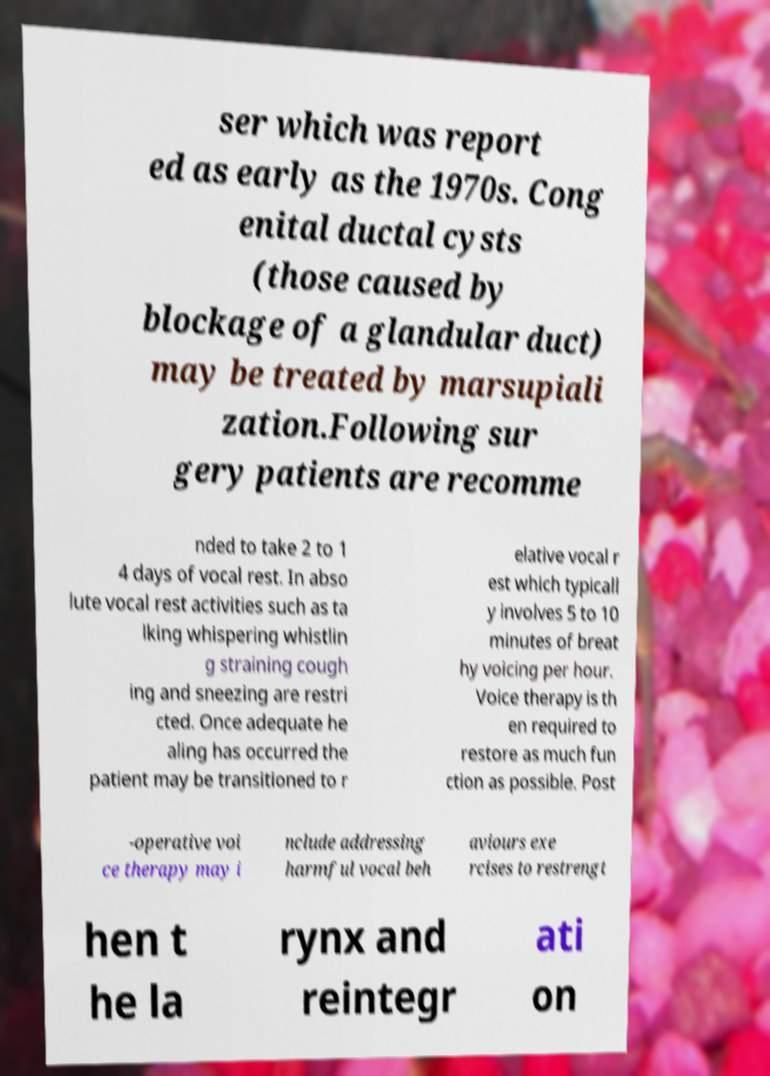Could you extract and type out the text from this image? ser which was report ed as early as the 1970s. Cong enital ductal cysts (those caused by blockage of a glandular duct) may be treated by marsupiali zation.Following sur gery patients are recomme nded to take 2 to 1 4 days of vocal rest. In abso lute vocal rest activities such as ta lking whispering whistlin g straining cough ing and sneezing are restri cted. Once adequate he aling has occurred the patient may be transitioned to r elative vocal r est which typicall y involves 5 to 10 minutes of breat hy voicing per hour. Voice therapy is th en required to restore as much fun ction as possible. Post -operative voi ce therapy may i nclude addressing harmful vocal beh aviours exe rcises to restrengt hen t he la rynx and reintegr ati on 